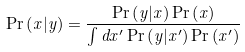<formula> <loc_0><loc_0><loc_500><loc_500>\Pr \left ( x | y \right ) = \frac { \Pr \left ( y | x \right ) \Pr \left ( x \right ) } { \int d x ^ { \prime } \Pr \left ( y | x ^ { \prime } \right ) \Pr \left ( x ^ { \prime } \right ) }</formula> 